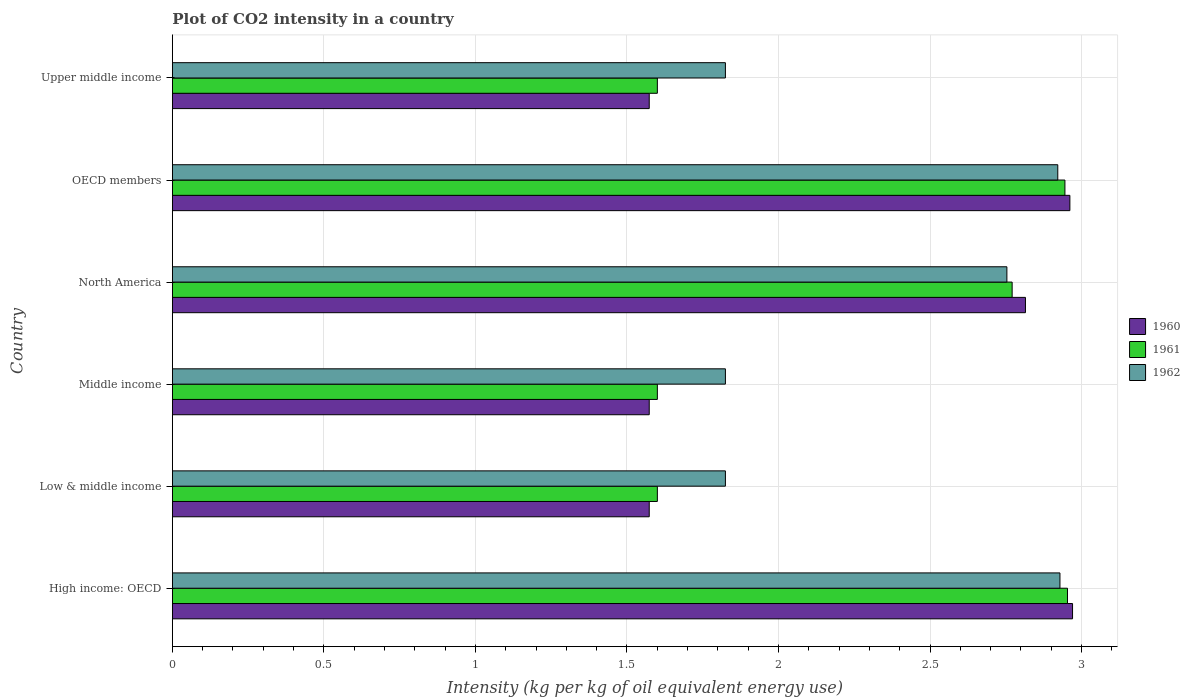Are the number of bars per tick equal to the number of legend labels?
Provide a short and direct response. Yes. What is the label of the 2nd group of bars from the top?
Make the answer very short. OECD members. What is the CO2 intensity in in 1961 in Low & middle income?
Provide a succinct answer. 1.6. Across all countries, what is the maximum CO2 intensity in in 1961?
Offer a terse response. 2.95. Across all countries, what is the minimum CO2 intensity in in 1962?
Your response must be concise. 1.82. In which country was the CO2 intensity in in 1961 maximum?
Your answer should be very brief. High income: OECD. In which country was the CO2 intensity in in 1962 minimum?
Your response must be concise. Low & middle income. What is the total CO2 intensity in in 1960 in the graph?
Provide a short and direct response. 13.47. What is the difference between the CO2 intensity in in 1962 in OECD members and that in Upper middle income?
Provide a short and direct response. 1.1. What is the difference between the CO2 intensity in in 1962 in North America and the CO2 intensity in in 1960 in Low & middle income?
Keep it short and to the point. 1.18. What is the average CO2 intensity in in 1961 per country?
Your answer should be very brief. 2.25. What is the difference between the CO2 intensity in in 1961 and CO2 intensity in in 1962 in Low & middle income?
Your answer should be very brief. -0.22. What is the ratio of the CO2 intensity in in 1961 in Low & middle income to that in Upper middle income?
Provide a short and direct response. 1. Is the CO2 intensity in in 1961 in Middle income less than that in OECD members?
Provide a short and direct response. Yes. What is the difference between the highest and the second highest CO2 intensity in in 1960?
Your answer should be very brief. 0.01. What is the difference between the highest and the lowest CO2 intensity in in 1962?
Give a very brief answer. 1.1. In how many countries, is the CO2 intensity in in 1961 greater than the average CO2 intensity in in 1961 taken over all countries?
Offer a terse response. 3. Is the sum of the CO2 intensity in in 1960 in Middle income and Upper middle income greater than the maximum CO2 intensity in in 1961 across all countries?
Give a very brief answer. Yes. Are all the bars in the graph horizontal?
Give a very brief answer. Yes. How many countries are there in the graph?
Make the answer very short. 6. What is the difference between two consecutive major ticks on the X-axis?
Your response must be concise. 0.5. Does the graph contain any zero values?
Offer a terse response. No. Does the graph contain grids?
Make the answer very short. Yes. Where does the legend appear in the graph?
Give a very brief answer. Center right. How many legend labels are there?
Your answer should be compact. 3. What is the title of the graph?
Make the answer very short. Plot of CO2 intensity in a country. Does "1989" appear as one of the legend labels in the graph?
Provide a succinct answer. No. What is the label or title of the X-axis?
Offer a very short reply. Intensity (kg per kg of oil equivalent energy use). What is the Intensity (kg per kg of oil equivalent energy use) of 1960 in High income: OECD?
Provide a short and direct response. 2.97. What is the Intensity (kg per kg of oil equivalent energy use) of 1961 in High income: OECD?
Offer a terse response. 2.95. What is the Intensity (kg per kg of oil equivalent energy use) in 1962 in High income: OECD?
Your answer should be compact. 2.93. What is the Intensity (kg per kg of oil equivalent energy use) of 1960 in Low & middle income?
Your answer should be compact. 1.57. What is the Intensity (kg per kg of oil equivalent energy use) in 1961 in Low & middle income?
Your response must be concise. 1.6. What is the Intensity (kg per kg of oil equivalent energy use) of 1962 in Low & middle income?
Offer a terse response. 1.82. What is the Intensity (kg per kg of oil equivalent energy use) of 1960 in Middle income?
Your answer should be very brief. 1.57. What is the Intensity (kg per kg of oil equivalent energy use) in 1961 in Middle income?
Your answer should be compact. 1.6. What is the Intensity (kg per kg of oil equivalent energy use) of 1962 in Middle income?
Ensure brevity in your answer.  1.82. What is the Intensity (kg per kg of oil equivalent energy use) in 1960 in North America?
Your answer should be compact. 2.81. What is the Intensity (kg per kg of oil equivalent energy use) of 1961 in North America?
Offer a very short reply. 2.77. What is the Intensity (kg per kg of oil equivalent energy use) in 1962 in North America?
Provide a short and direct response. 2.75. What is the Intensity (kg per kg of oil equivalent energy use) in 1960 in OECD members?
Make the answer very short. 2.96. What is the Intensity (kg per kg of oil equivalent energy use) in 1961 in OECD members?
Give a very brief answer. 2.95. What is the Intensity (kg per kg of oil equivalent energy use) of 1962 in OECD members?
Offer a very short reply. 2.92. What is the Intensity (kg per kg of oil equivalent energy use) in 1960 in Upper middle income?
Ensure brevity in your answer.  1.57. What is the Intensity (kg per kg of oil equivalent energy use) of 1961 in Upper middle income?
Provide a succinct answer. 1.6. What is the Intensity (kg per kg of oil equivalent energy use) of 1962 in Upper middle income?
Provide a succinct answer. 1.82. Across all countries, what is the maximum Intensity (kg per kg of oil equivalent energy use) of 1960?
Provide a succinct answer. 2.97. Across all countries, what is the maximum Intensity (kg per kg of oil equivalent energy use) in 1961?
Your response must be concise. 2.95. Across all countries, what is the maximum Intensity (kg per kg of oil equivalent energy use) in 1962?
Your answer should be very brief. 2.93. Across all countries, what is the minimum Intensity (kg per kg of oil equivalent energy use) of 1960?
Make the answer very short. 1.57. Across all countries, what is the minimum Intensity (kg per kg of oil equivalent energy use) in 1961?
Offer a very short reply. 1.6. Across all countries, what is the minimum Intensity (kg per kg of oil equivalent energy use) of 1962?
Keep it short and to the point. 1.82. What is the total Intensity (kg per kg of oil equivalent energy use) in 1960 in the graph?
Keep it short and to the point. 13.47. What is the total Intensity (kg per kg of oil equivalent energy use) of 1961 in the graph?
Offer a very short reply. 13.47. What is the total Intensity (kg per kg of oil equivalent energy use) of 1962 in the graph?
Provide a short and direct response. 14.08. What is the difference between the Intensity (kg per kg of oil equivalent energy use) in 1960 in High income: OECD and that in Low & middle income?
Provide a succinct answer. 1.4. What is the difference between the Intensity (kg per kg of oil equivalent energy use) in 1961 in High income: OECD and that in Low & middle income?
Offer a terse response. 1.35. What is the difference between the Intensity (kg per kg of oil equivalent energy use) in 1962 in High income: OECD and that in Low & middle income?
Provide a succinct answer. 1.1. What is the difference between the Intensity (kg per kg of oil equivalent energy use) in 1960 in High income: OECD and that in Middle income?
Keep it short and to the point. 1.4. What is the difference between the Intensity (kg per kg of oil equivalent energy use) of 1961 in High income: OECD and that in Middle income?
Your answer should be very brief. 1.35. What is the difference between the Intensity (kg per kg of oil equivalent energy use) in 1962 in High income: OECD and that in Middle income?
Provide a succinct answer. 1.1. What is the difference between the Intensity (kg per kg of oil equivalent energy use) in 1960 in High income: OECD and that in North America?
Provide a succinct answer. 0.16. What is the difference between the Intensity (kg per kg of oil equivalent energy use) of 1961 in High income: OECD and that in North America?
Give a very brief answer. 0.18. What is the difference between the Intensity (kg per kg of oil equivalent energy use) in 1962 in High income: OECD and that in North America?
Offer a very short reply. 0.18. What is the difference between the Intensity (kg per kg of oil equivalent energy use) in 1960 in High income: OECD and that in OECD members?
Make the answer very short. 0.01. What is the difference between the Intensity (kg per kg of oil equivalent energy use) in 1961 in High income: OECD and that in OECD members?
Offer a terse response. 0.01. What is the difference between the Intensity (kg per kg of oil equivalent energy use) of 1962 in High income: OECD and that in OECD members?
Give a very brief answer. 0.01. What is the difference between the Intensity (kg per kg of oil equivalent energy use) of 1960 in High income: OECD and that in Upper middle income?
Give a very brief answer. 1.4. What is the difference between the Intensity (kg per kg of oil equivalent energy use) of 1961 in High income: OECD and that in Upper middle income?
Keep it short and to the point. 1.35. What is the difference between the Intensity (kg per kg of oil equivalent energy use) in 1962 in High income: OECD and that in Upper middle income?
Provide a succinct answer. 1.1. What is the difference between the Intensity (kg per kg of oil equivalent energy use) in 1961 in Low & middle income and that in Middle income?
Ensure brevity in your answer.  0. What is the difference between the Intensity (kg per kg of oil equivalent energy use) in 1960 in Low & middle income and that in North America?
Ensure brevity in your answer.  -1.24. What is the difference between the Intensity (kg per kg of oil equivalent energy use) in 1961 in Low & middle income and that in North America?
Make the answer very short. -1.17. What is the difference between the Intensity (kg per kg of oil equivalent energy use) in 1962 in Low & middle income and that in North America?
Your answer should be very brief. -0.93. What is the difference between the Intensity (kg per kg of oil equivalent energy use) of 1960 in Low & middle income and that in OECD members?
Keep it short and to the point. -1.39. What is the difference between the Intensity (kg per kg of oil equivalent energy use) in 1961 in Low & middle income and that in OECD members?
Your response must be concise. -1.34. What is the difference between the Intensity (kg per kg of oil equivalent energy use) in 1962 in Low & middle income and that in OECD members?
Provide a short and direct response. -1.1. What is the difference between the Intensity (kg per kg of oil equivalent energy use) in 1960 in Low & middle income and that in Upper middle income?
Your response must be concise. 0. What is the difference between the Intensity (kg per kg of oil equivalent energy use) of 1961 in Low & middle income and that in Upper middle income?
Offer a very short reply. 0. What is the difference between the Intensity (kg per kg of oil equivalent energy use) in 1960 in Middle income and that in North America?
Give a very brief answer. -1.24. What is the difference between the Intensity (kg per kg of oil equivalent energy use) in 1961 in Middle income and that in North America?
Offer a terse response. -1.17. What is the difference between the Intensity (kg per kg of oil equivalent energy use) in 1962 in Middle income and that in North America?
Your answer should be very brief. -0.93. What is the difference between the Intensity (kg per kg of oil equivalent energy use) in 1960 in Middle income and that in OECD members?
Your response must be concise. -1.39. What is the difference between the Intensity (kg per kg of oil equivalent energy use) of 1961 in Middle income and that in OECD members?
Keep it short and to the point. -1.34. What is the difference between the Intensity (kg per kg of oil equivalent energy use) in 1962 in Middle income and that in OECD members?
Provide a succinct answer. -1.1. What is the difference between the Intensity (kg per kg of oil equivalent energy use) in 1961 in Middle income and that in Upper middle income?
Give a very brief answer. 0. What is the difference between the Intensity (kg per kg of oil equivalent energy use) of 1962 in Middle income and that in Upper middle income?
Make the answer very short. 0. What is the difference between the Intensity (kg per kg of oil equivalent energy use) of 1960 in North America and that in OECD members?
Your response must be concise. -0.15. What is the difference between the Intensity (kg per kg of oil equivalent energy use) of 1961 in North America and that in OECD members?
Ensure brevity in your answer.  -0.17. What is the difference between the Intensity (kg per kg of oil equivalent energy use) in 1962 in North America and that in OECD members?
Provide a succinct answer. -0.17. What is the difference between the Intensity (kg per kg of oil equivalent energy use) in 1960 in North America and that in Upper middle income?
Your answer should be compact. 1.24. What is the difference between the Intensity (kg per kg of oil equivalent energy use) of 1961 in North America and that in Upper middle income?
Provide a short and direct response. 1.17. What is the difference between the Intensity (kg per kg of oil equivalent energy use) of 1962 in North America and that in Upper middle income?
Your answer should be compact. 0.93. What is the difference between the Intensity (kg per kg of oil equivalent energy use) of 1960 in OECD members and that in Upper middle income?
Offer a very short reply. 1.39. What is the difference between the Intensity (kg per kg of oil equivalent energy use) in 1961 in OECD members and that in Upper middle income?
Keep it short and to the point. 1.34. What is the difference between the Intensity (kg per kg of oil equivalent energy use) of 1962 in OECD members and that in Upper middle income?
Offer a terse response. 1.1. What is the difference between the Intensity (kg per kg of oil equivalent energy use) in 1960 in High income: OECD and the Intensity (kg per kg of oil equivalent energy use) in 1961 in Low & middle income?
Provide a short and direct response. 1.37. What is the difference between the Intensity (kg per kg of oil equivalent energy use) in 1960 in High income: OECD and the Intensity (kg per kg of oil equivalent energy use) in 1962 in Low & middle income?
Give a very brief answer. 1.15. What is the difference between the Intensity (kg per kg of oil equivalent energy use) of 1961 in High income: OECD and the Intensity (kg per kg of oil equivalent energy use) of 1962 in Low & middle income?
Provide a succinct answer. 1.13. What is the difference between the Intensity (kg per kg of oil equivalent energy use) of 1960 in High income: OECD and the Intensity (kg per kg of oil equivalent energy use) of 1961 in Middle income?
Offer a terse response. 1.37. What is the difference between the Intensity (kg per kg of oil equivalent energy use) in 1960 in High income: OECD and the Intensity (kg per kg of oil equivalent energy use) in 1962 in Middle income?
Give a very brief answer. 1.15. What is the difference between the Intensity (kg per kg of oil equivalent energy use) of 1961 in High income: OECD and the Intensity (kg per kg of oil equivalent energy use) of 1962 in Middle income?
Make the answer very short. 1.13. What is the difference between the Intensity (kg per kg of oil equivalent energy use) of 1960 in High income: OECD and the Intensity (kg per kg of oil equivalent energy use) of 1961 in North America?
Offer a terse response. 0.2. What is the difference between the Intensity (kg per kg of oil equivalent energy use) of 1960 in High income: OECD and the Intensity (kg per kg of oil equivalent energy use) of 1962 in North America?
Provide a short and direct response. 0.22. What is the difference between the Intensity (kg per kg of oil equivalent energy use) in 1961 in High income: OECD and the Intensity (kg per kg of oil equivalent energy use) in 1962 in North America?
Provide a short and direct response. 0.2. What is the difference between the Intensity (kg per kg of oil equivalent energy use) in 1960 in High income: OECD and the Intensity (kg per kg of oil equivalent energy use) in 1961 in OECD members?
Your response must be concise. 0.03. What is the difference between the Intensity (kg per kg of oil equivalent energy use) of 1960 in High income: OECD and the Intensity (kg per kg of oil equivalent energy use) of 1962 in OECD members?
Offer a very short reply. 0.05. What is the difference between the Intensity (kg per kg of oil equivalent energy use) in 1961 in High income: OECD and the Intensity (kg per kg of oil equivalent energy use) in 1962 in OECD members?
Offer a very short reply. 0.03. What is the difference between the Intensity (kg per kg of oil equivalent energy use) of 1960 in High income: OECD and the Intensity (kg per kg of oil equivalent energy use) of 1961 in Upper middle income?
Offer a very short reply. 1.37. What is the difference between the Intensity (kg per kg of oil equivalent energy use) in 1960 in High income: OECD and the Intensity (kg per kg of oil equivalent energy use) in 1962 in Upper middle income?
Provide a succinct answer. 1.15. What is the difference between the Intensity (kg per kg of oil equivalent energy use) in 1961 in High income: OECD and the Intensity (kg per kg of oil equivalent energy use) in 1962 in Upper middle income?
Offer a terse response. 1.13. What is the difference between the Intensity (kg per kg of oil equivalent energy use) of 1960 in Low & middle income and the Intensity (kg per kg of oil equivalent energy use) of 1961 in Middle income?
Offer a very short reply. -0.03. What is the difference between the Intensity (kg per kg of oil equivalent energy use) in 1960 in Low & middle income and the Intensity (kg per kg of oil equivalent energy use) in 1962 in Middle income?
Give a very brief answer. -0.25. What is the difference between the Intensity (kg per kg of oil equivalent energy use) in 1961 in Low & middle income and the Intensity (kg per kg of oil equivalent energy use) in 1962 in Middle income?
Your answer should be compact. -0.22. What is the difference between the Intensity (kg per kg of oil equivalent energy use) in 1960 in Low & middle income and the Intensity (kg per kg of oil equivalent energy use) in 1961 in North America?
Make the answer very short. -1.2. What is the difference between the Intensity (kg per kg of oil equivalent energy use) of 1960 in Low & middle income and the Intensity (kg per kg of oil equivalent energy use) of 1962 in North America?
Offer a very short reply. -1.18. What is the difference between the Intensity (kg per kg of oil equivalent energy use) in 1961 in Low & middle income and the Intensity (kg per kg of oil equivalent energy use) in 1962 in North America?
Your answer should be very brief. -1.15. What is the difference between the Intensity (kg per kg of oil equivalent energy use) in 1960 in Low & middle income and the Intensity (kg per kg of oil equivalent energy use) in 1961 in OECD members?
Your answer should be compact. -1.37. What is the difference between the Intensity (kg per kg of oil equivalent energy use) of 1960 in Low & middle income and the Intensity (kg per kg of oil equivalent energy use) of 1962 in OECD members?
Your response must be concise. -1.35. What is the difference between the Intensity (kg per kg of oil equivalent energy use) of 1961 in Low & middle income and the Intensity (kg per kg of oil equivalent energy use) of 1962 in OECD members?
Provide a succinct answer. -1.32. What is the difference between the Intensity (kg per kg of oil equivalent energy use) in 1960 in Low & middle income and the Intensity (kg per kg of oil equivalent energy use) in 1961 in Upper middle income?
Make the answer very short. -0.03. What is the difference between the Intensity (kg per kg of oil equivalent energy use) of 1960 in Low & middle income and the Intensity (kg per kg of oil equivalent energy use) of 1962 in Upper middle income?
Give a very brief answer. -0.25. What is the difference between the Intensity (kg per kg of oil equivalent energy use) in 1961 in Low & middle income and the Intensity (kg per kg of oil equivalent energy use) in 1962 in Upper middle income?
Your response must be concise. -0.22. What is the difference between the Intensity (kg per kg of oil equivalent energy use) of 1960 in Middle income and the Intensity (kg per kg of oil equivalent energy use) of 1961 in North America?
Your response must be concise. -1.2. What is the difference between the Intensity (kg per kg of oil equivalent energy use) in 1960 in Middle income and the Intensity (kg per kg of oil equivalent energy use) in 1962 in North America?
Keep it short and to the point. -1.18. What is the difference between the Intensity (kg per kg of oil equivalent energy use) of 1961 in Middle income and the Intensity (kg per kg of oil equivalent energy use) of 1962 in North America?
Your answer should be compact. -1.15. What is the difference between the Intensity (kg per kg of oil equivalent energy use) in 1960 in Middle income and the Intensity (kg per kg of oil equivalent energy use) in 1961 in OECD members?
Make the answer very short. -1.37. What is the difference between the Intensity (kg per kg of oil equivalent energy use) of 1960 in Middle income and the Intensity (kg per kg of oil equivalent energy use) of 1962 in OECD members?
Your answer should be very brief. -1.35. What is the difference between the Intensity (kg per kg of oil equivalent energy use) in 1961 in Middle income and the Intensity (kg per kg of oil equivalent energy use) in 1962 in OECD members?
Offer a terse response. -1.32. What is the difference between the Intensity (kg per kg of oil equivalent energy use) in 1960 in Middle income and the Intensity (kg per kg of oil equivalent energy use) in 1961 in Upper middle income?
Provide a short and direct response. -0.03. What is the difference between the Intensity (kg per kg of oil equivalent energy use) of 1960 in Middle income and the Intensity (kg per kg of oil equivalent energy use) of 1962 in Upper middle income?
Your answer should be compact. -0.25. What is the difference between the Intensity (kg per kg of oil equivalent energy use) of 1961 in Middle income and the Intensity (kg per kg of oil equivalent energy use) of 1962 in Upper middle income?
Your response must be concise. -0.22. What is the difference between the Intensity (kg per kg of oil equivalent energy use) of 1960 in North America and the Intensity (kg per kg of oil equivalent energy use) of 1961 in OECD members?
Ensure brevity in your answer.  -0.13. What is the difference between the Intensity (kg per kg of oil equivalent energy use) of 1960 in North America and the Intensity (kg per kg of oil equivalent energy use) of 1962 in OECD members?
Provide a succinct answer. -0.11. What is the difference between the Intensity (kg per kg of oil equivalent energy use) of 1961 in North America and the Intensity (kg per kg of oil equivalent energy use) of 1962 in OECD members?
Offer a very short reply. -0.15. What is the difference between the Intensity (kg per kg of oil equivalent energy use) of 1960 in North America and the Intensity (kg per kg of oil equivalent energy use) of 1961 in Upper middle income?
Your answer should be compact. 1.21. What is the difference between the Intensity (kg per kg of oil equivalent energy use) of 1960 in North America and the Intensity (kg per kg of oil equivalent energy use) of 1962 in Upper middle income?
Provide a succinct answer. 0.99. What is the difference between the Intensity (kg per kg of oil equivalent energy use) in 1961 in North America and the Intensity (kg per kg of oil equivalent energy use) in 1962 in Upper middle income?
Give a very brief answer. 0.95. What is the difference between the Intensity (kg per kg of oil equivalent energy use) in 1960 in OECD members and the Intensity (kg per kg of oil equivalent energy use) in 1961 in Upper middle income?
Make the answer very short. 1.36. What is the difference between the Intensity (kg per kg of oil equivalent energy use) of 1960 in OECD members and the Intensity (kg per kg of oil equivalent energy use) of 1962 in Upper middle income?
Your answer should be compact. 1.14. What is the difference between the Intensity (kg per kg of oil equivalent energy use) of 1961 in OECD members and the Intensity (kg per kg of oil equivalent energy use) of 1962 in Upper middle income?
Offer a terse response. 1.12. What is the average Intensity (kg per kg of oil equivalent energy use) of 1960 per country?
Ensure brevity in your answer.  2.24. What is the average Intensity (kg per kg of oil equivalent energy use) of 1961 per country?
Ensure brevity in your answer.  2.25. What is the average Intensity (kg per kg of oil equivalent energy use) of 1962 per country?
Make the answer very short. 2.35. What is the difference between the Intensity (kg per kg of oil equivalent energy use) of 1960 and Intensity (kg per kg of oil equivalent energy use) of 1961 in High income: OECD?
Provide a short and direct response. 0.02. What is the difference between the Intensity (kg per kg of oil equivalent energy use) of 1960 and Intensity (kg per kg of oil equivalent energy use) of 1962 in High income: OECD?
Give a very brief answer. 0.04. What is the difference between the Intensity (kg per kg of oil equivalent energy use) of 1961 and Intensity (kg per kg of oil equivalent energy use) of 1962 in High income: OECD?
Offer a very short reply. 0.02. What is the difference between the Intensity (kg per kg of oil equivalent energy use) of 1960 and Intensity (kg per kg of oil equivalent energy use) of 1961 in Low & middle income?
Offer a very short reply. -0.03. What is the difference between the Intensity (kg per kg of oil equivalent energy use) of 1960 and Intensity (kg per kg of oil equivalent energy use) of 1962 in Low & middle income?
Make the answer very short. -0.25. What is the difference between the Intensity (kg per kg of oil equivalent energy use) of 1961 and Intensity (kg per kg of oil equivalent energy use) of 1962 in Low & middle income?
Your answer should be very brief. -0.22. What is the difference between the Intensity (kg per kg of oil equivalent energy use) of 1960 and Intensity (kg per kg of oil equivalent energy use) of 1961 in Middle income?
Give a very brief answer. -0.03. What is the difference between the Intensity (kg per kg of oil equivalent energy use) in 1960 and Intensity (kg per kg of oil equivalent energy use) in 1962 in Middle income?
Give a very brief answer. -0.25. What is the difference between the Intensity (kg per kg of oil equivalent energy use) of 1961 and Intensity (kg per kg of oil equivalent energy use) of 1962 in Middle income?
Offer a terse response. -0.22. What is the difference between the Intensity (kg per kg of oil equivalent energy use) in 1960 and Intensity (kg per kg of oil equivalent energy use) in 1961 in North America?
Make the answer very short. 0.04. What is the difference between the Intensity (kg per kg of oil equivalent energy use) in 1960 and Intensity (kg per kg of oil equivalent energy use) in 1962 in North America?
Provide a short and direct response. 0.06. What is the difference between the Intensity (kg per kg of oil equivalent energy use) of 1961 and Intensity (kg per kg of oil equivalent energy use) of 1962 in North America?
Keep it short and to the point. 0.02. What is the difference between the Intensity (kg per kg of oil equivalent energy use) of 1960 and Intensity (kg per kg of oil equivalent energy use) of 1961 in OECD members?
Your answer should be very brief. 0.02. What is the difference between the Intensity (kg per kg of oil equivalent energy use) in 1960 and Intensity (kg per kg of oil equivalent energy use) in 1962 in OECD members?
Ensure brevity in your answer.  0.04. What is the difference between the Intensity (kg per kg of oil equivalent energy use) in 1961 and Intensity (kg per kg of oil equivalent energy use) in 1962 in OECD members?
Your answer should be very brief. 0.02. What is the difference between the Intensity (kg per kg of oil equivalent energy use) of 1960 and Intensity (kg per kg of oil equivalent energy use) of 1961 in Upper middle income?
Your response must be concise. -0.03. What is the difference between the Intensity (kg per kg of oil equivalent energy use) in 1960 and Intensity (kg per kg of oil equivalent energy use) in 1962 in Upper middle income?
Your answer should be very brief. -0.25. What is the difference between the Intensity (kg per kg of oil equivalent energy use) of 1961 and Intensity (kg per kg of oil equivalent energy use) of 1962 in Upper middle income?
Provide a short and direct response. -0.22. What is the ratio of the Intensity (kg per kg of oil equivalent energy use) of 1960 in High income: OECD to that in Low & middle income?
Offer a very short reply. 1.89. What is the ratio of the Intensity (kg per kg of oil equivalent energy use) of 1961 in High income: OECD to that in Low & middle income?
Give a very brief answer. 1.85. What is the ratio of the Intensity (kg per kg of oil equivalent energy use) in 1962 in High income: OECD to that in Low & middle income?
Give a very brief answer. 1.6. What is the ratio of the Intensity (kg per kg of oil equivalent energy use) in 1960 in High income: OECD to that in Middle income?
Offer a very short reply. 1.89. What is the ratio of the Intensity (kg per kg of oil equivalent energy use) of 1961 in High income: OECD to that in Middle income?
Offer a very short reply. 1.85. What is the ratio of the Intensity (kg per kg of oil equivalent energy use) in 1962 in High income: OECD to that in Middle income?
Offer a terse response. 1.6. What is the ratio of the Intensity (kg per kg of oil equivalent energy use) in 1960 in High income: OECD to that in North America?
Offer a terse response. 1.06. What is the ratio of the Intensity (kg per kg of oil equivalent energy use) in 1961 in High income: OECD to that in North America?
Provide a succinct answer. 1.07. What is the ratio of the Intensity (kg per kg of oil equivalent energy use) of 1962 in High income: OECD to that in North America?
Keep it short and to the point. 1.06. What is the ratio of the Intensity (kg per kg of oil equivalent energy use) in 1960 in High income: OECD to that in OECD members?
Provide a short and direct response. 1. What is the ratio of the Intensity (kg per kg of oil equivalent energy use) in 1960 in High income: OECD to that in Upper middle income?
Provide a short and direct response. 1.89. What is the ratio of the Intensity (kg per kg of oil equivalent energy use) of 1961 in High income: OECD to that in Upper middle income?
Give a very brief answer. 1.85. What is the ratio of the Intensity (kg per kg of oil equivalent energy use) in 1962 in High income: OECD to that in Upper middle income?
Keep it short and to the point. 1.6. What is the ratio of the Intensity (kg per kg of oil equivalent energy use) in 1960 in Low & middle income to that in Middle income?
Make the answer very short. 1. What is the ratio of the Intensity (kg per kg of oil equivalent energy use) of 1961 in Low & middle income to that in Middle income?
Provide a succinct answer. 1. What is the ratio of the Intensity (kg per kg of oil equivalent energy use) in 1960 in Low & middle income to that in North America?
Give a very brief answer. 0.56. What is the ratio of the Intensity (kg per kg of oil equivalent energy use) of 1961 in Low & middle income to that in North America?
Your answer should be compact. 0.58. What is the ratio of the Intensity (kg per kg of oil equivalent energy use) in 1962 in Low & middle income to that in North America?
Provide a short and direct response. 0.66. What is the ratio of the Intensity (kg per kg of oil equivalent energy use) in 1960 in Low & middle income to that in OECD members?
Provide a succinct answer. 0.53. What is the ratio of the Intensity (kg per kg of oil equivalent energy use) of 1961 in Low & middle income to that in OECD members?
Make the answer very short. 0.54. What is the ratio of the Intensity (kg per kg of oil equivalent energy use) of 1962 in Low & middle income to that in OECD members?
Your response must be concise. 0.62. What is the ratio of the Intensity (kg per kg of oil equivalent energy use) in 1960 in Low & middle income to that in Upper middle income?
Provide a short and direct response. 1. What is the ratio of the Intensity (kg per kg of oil equivalent energy use) in 1961 in Low & middle income to that in Upper middle income?
Your answer should be very brief. 1. What is the ratio of the Intensity (kg per kg of oil equivalent energy use) in 1960 in Middle income to that in North America?
Give a very brief answer. 0.56. What is the ratio of the Intensity (kg per kg of oil equivalent energy use) in 1961 in Middle income to that in North America?
Your answer should be compact. 0.58. What is the ratio of the Intensity (kg per kg of oil equivalent energy use) of 1962 in Middle income to that in North America?
Your answer should be compact. 0.66. What is the ratio of the Intensity (kg per kg of oil equivalent energy use) of 1960 in Middle income to that in OECD members?
Provide a succinct answer. 0.53. What is the ratio of the Intensity (kg per kg of oil equivalent energy use) in 1961 in Middle income to that in OECD members?
Your answer should be very brief. 0.54. What is the ratio of the Intensity (kg per kg of oil equivalent energy use) of 1962 in Middle income to that in OECD members?
Provide a succinct answer. 0.62. What is the ratio of the Intensity (kg per kg of oil equivalent energy use) in 1960 in Middle income to that in Upper middle income?
Keep it short and to the point. 1. What is the ratio of the Intensity (kg per kg of oil equivalent energy use) in 1962 in Middle income to that in Upper middle income?
Your answer should be very brief. 1. What is the ratio of the Intensity (kg per kg of oil equivalent energy use) of 1960 in North America to that in OECD members?
Your answer should be very brief. 0.95. What is the ratio of the Intensity (kg per kg of oil equivalent energy use) in 1961 in North America to that in OECD members?
Provide a succinct answer. 0.94. What is the ratio of the Intensity (kg per kg of oil equivalent energy use) of 1962 in North America to that in OECD members?
Offer a very short reply. 0.94. What is the ratio of the Intensity (kg per kg of oil equivalent energy use) of 1960 in North America to that in Upper middle income?
Your answer should be very brief. 1.79. What is the ratio of the Intensity (kg per kg of oil equivalent energy use) in 1961 in North America to that in Upper middle income?
Your response must be concise. 1.73. What is the ratio of the Intensity (kg per kg of oil equivalent energy use) of 1962 in North America to that in Upper middle income?
Provide a short and direct response. 1.51. What is the ratio of the Intensity (kg per kg of oil equivalent energy use) in 1960 in OECD members to that in Upper middle income?
Offer a terse response. 1.88. What is the ratio of the Intensity (kg per kg of oil equivalent energy use) of 1961 in OECD members to that in Upper middle income?
Your answer should be compact. 1.84. What is the ratio of the Intensity (kg per kg of oil equivalent energy use) in 1962 in OECD members to that in Upper middle income?
Give a very brief answer. 1.6. What is the difference between the highest and the second highest Intensity (kg per kg of oil equivalent energy use) of 1960?
Your answer should be compact. 0.01. What is the difference between the highest and the second highest Intensity (kg per kg of oil equivalent energy use) of 1961?
Offer a terse response. 0.01. What is the difference between the highest and the second highest Intensity (kg per kg of oil equivalent energy use) of 1962?
Your response must be concise. 0.01. What is the difference between the highest and the lowest Intensity (kg per kg of oil equivalent energy use) in 1960?
Give a very brief answer. 1.4. What is the difference between the highest and the lowest Intensity (kg per kg of oil equivalent energy use) of 1961?
Your answer should be very brief. 1.35. What is the difference between the highest and the lowest Intensity (kg per kg of oil equivalent energy use) of 1962?
Ensure brevity in your answer.  1.1. 